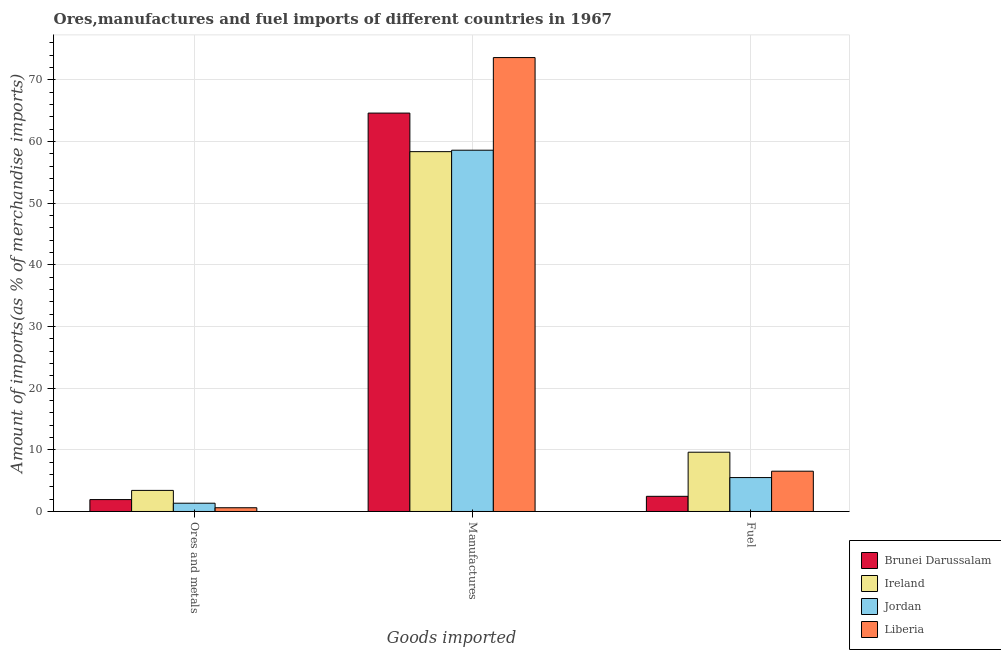How many different coloured bars are there?
Offer a very short reply. 4. How many groups of bars are there?
Keep it short and to the point. 3. What is the label of the 3rd group of bars from the left?
Make the answer very short. Fuel. What is the percentage of manufactures imports in Brunei Darussalam?
Your response must be concise. 64.62. Across all countries, what is the maximum percentage of fuel imports?
Make the answer very short. 9.61. Across all countries, what is the minimum percentage of manufactures imports?
Make the answer very short. 58.36. In which country was the percentage of fuel imports maximum?
Your answer should be very brief. Ireland. In which country was the percentage of fuel imports minimum?
Ensure brevity in your answer.  Brunei Darussalam. What is the total percentage of manufactures imports in the graph?
Your response must be concise. 255.2. What is the difference between the percentage of fuel imports in Ireland and that in Jordan?
Your response must be concise. 4.12. What is the difference between the percentage of manufactures imports in Brunei Darussalam and the percentage of fuel imports in Liberia?
Offer a terse response. 58.08. What is the average percentage of manufactures imports per country?
Offer a terse response. 63.8. What is the difference between the percentage of ores and metals imports and percentage of fuel imports in Jordan?
Provide a succinct answer. -4.16. What is the ratio of the percentage of fuel imports in Brunei Darussalam to that in Ireland?
Provide a short and direct response. 0.26. Is the difference between the percentage of ores and metals imports in Liberia and Jordan greater than the difference between the percentage of manufactures imports in Liberia and Jordan?
Keep it short and to the point. No. What is the difference between the highest and the second highest percentage of fuel imports?
Your answer should be very brief. 3.08. What is the difference between the highest and the lowest percentage of manufactures imports?
Make the answer very short. 15.26. Is the sum of the percentage of manufactures imports in Liberia and Jordan greater than the maximum percentage of ores and metals imports across all countries?
Your response must be concise. Yes. What does the 4th bar from the left in Ores and metals represents?
Your answer should be compact. Liberia. What does the 2nd bar from the right in Ores and metals represents?
Provide a succinct answer. Jordan. Is it the case that in every country, the sum of the percentage of ores and metals imports and percentage of manufactures imports is greater than the percentage of fuel imports?
Ensure brevity in your answer.  Yes. How many countries are there in the graph?
Your answer should be very brief. 4. What is the difference between two consecutive major ticks on the Y-axis?
Offer a terse response. 10. Does the graph contain any zero values?
Provide a succinct answer. No. Does the graph contain grids?
Ensure brevity in your answer.  Yes. What is the title of the graph?
Provide a succinct answer. Ores,manufactures and fuel imports of different countries in 1967. What is the label or title of the X-axis?
Your answer should be very brief. Goods imported. What is the label or title of the Y-axis?
Keep it short and to the point. Amount of imports(as % of merchandise imports). What is the Amount of imports(as % of merchandise imports) of Brunei Darussalam in Ores and metals?
Your answer should be very brief. 1.93. What is the Amount of imports(as % of merchandise imports) of Ireland in Ores and metals?
Offer a terse response. 3.42. What is the Amount of imports(as % of merchandise imports) of Jordan in Ores and metals?
Give a very brief answer. 1.34. What is the Amount of imports(as % of merchandise imports) in Liberia in Ores and metals?
Offer a terse response. 0.61. What is the Amount of imports(as % of merchandise imports) of Brunei Darussalam in Manufactures?
Ensure brevity in your answer.  64.62. What is the Amount of imports(as % of merchandise imports) in Ireland in Manufactures?
Your response must be concise. 58.36. What is the Amount of imports(as % of merchandise imports) of Jordan in Manufactures?
Offer a very short reply. 58.6. What is the Amount of imports(as % of merchandise imports) in Liberia in Manufactures?
Make the answer very short. 73.62. What is the Amount of imports(as % of merchandise imports) of Brunei Darussalam in Fuel?
Keep it short and to the point. 2.46. What is the Amount of imports(as % of merchandise imports) of Ireland in Fuel?
Provide a short and direct response. 9.61. What is the Amount of imports(as % of merchandise imports) in Jordan in Fuel?
Provide a succinct answer. 5.5. What is the Amount of imports(as % of merchandise imports) in Liberia in Fuel?
Offer a terse response. 6.53. Across all Goods imported, what is the maximum Amount of imports(as % of merchandise imports) of Brunei Darussalam?
Give a very brief answer. 64.62. Across all Goods imported, what is the maximum Amount of imports(as % of merchandise imports) in Ireland?
Provide a succinct answer. 58.36. Across all Goods imported, what is the maximum Amount of imports(as % of merchandise imports) in Jordan?
Provide a succinct answer. 58.6. Across all Goods imported, what is the maximum Amount of imports(as % of merchandise imports) in Liberia?
Your answer should be very brief. 73.62. Across all Goods imported, what is the minimum Amount of imports(as % of merchandise imports) of Brunei Darussalam?
Offer a terse response. 1.93. Across all Goods imported, what is the minimum Amount of imports(as % of merchandise imports) in Ireland?
Your answer should be very brief. 3.42. Across all Goods imported, what is the minimum Amount of imports(as % of merchandise imports) in Jordan?
Your response must be concise. 1.34. Across all Goods imported, what is the minimum Amount of imports(as % of merchandise imports) of Liberia?
Your answer should be very brief. 0.61. What is the total Amount of imports(as % of merchandise imports) in Brunei Darussalam in the graph?
Provide a short and direct response. 69.01. What is the total Amount of imports(as % of merchandise imports) in Ireland in the graph?
Make the answer very short. 71.4. What is the total Amount of imports(as % of merchandise imports) in Jordan in the graph?
Offer a very short reply. 65.44. What is the total Amount of imports(as % of merchandise imports) in Liberia in the graph?
Your answer should be compact. 80.76. What is the difference between the Amount of imports(as % of merchandise imports) in Brunei Darussalam in Ores and metals and that in Manufactures?
Ensure brevity in your answer.  -62.69. What is the difference between the Amount of imports(as % of merchandise imports) of Ireland in Ores and metals and that in Manufactures?
Provide a succinct answer. -54.94. What is the difference between the Amount of imports(as % of merchandise imports) in Jordan in Ores and metals and that in Manufactures?
Your response must be concise. -57.25. What is the difference between the Amount of imports(as % of merchandise imports) in Liberia in Ores and metals and that in Manufactures?
Offer a terse response. -73.01. What is the difference between the Amount of imports(as % of merchandise imports) in Brunei Darussalam in Ores and metals and that in Fuel?
Offer a terse response. -0.53. What is the difference between the Amount of imports(as % of merchandise imports) of Ireland in Ores and metals and that in Fuel?
Keep it short and to the point. -6.19. What is the difference between the Amount of imports(as % of merchandise imports) of Jordan in Ores and metals and that in Fuel?
Give a very brief answer. -4.16. What is the difference between the Amount of imports(as % of merchandise imports) in Liberia in Ores and metals and that in Fuel?
Give a very brief answer. -5.93. What is the difference between the Amount of imports(as % of merchandise imports) in Brunei Darussalam in Manufactures and that in Fuel?
Your response must be concise. 62.16. What is the difference between the Amount of imports(as % of merchandise imports) of Ireland in Manufactures and that in Fuel?
Your response must be concise. 48.75. What is the difference between the Amount of imports(as % of merchandise imports) in Jordan in Manufactures and that in Fuel?
Your response must be concise. 53.1. What is the difference between the Amount of imports(as % of merchandise imports) in Liberia in Manufactures and that in Fuel?
Provide a short and direct response. 67.09. What is the difference between the Amount of imports(as % of merchandise imports) of Brunei Darussalam in Ores and metals and the Amount of imports(as % of merchandise imports) of Ireland in Manufactures?
Offer a terse response. -56.43. What is the difference between the Amount of imports(as % of merchandise imports) in Brunei Darussalam in Ores and metals and the Amount of imports(as % of merchandise imports) in Jordan in Manufactures?
Offer a terse response. -56.67. What is the difference between the Amount of imports(as % of merchandise imports) of Brunei Darussalam in Ores and metals and the Amount of imports(as % of merchandise imports) of Liberia in Manufactures?
Give a very brief answer. -71.69. What is the difference between the Amount of imports(as % of merchandise imports) of Ireland in Ores and metals and the Amount of imports(as % of merchandise imports) of Jordan in Manufactures?
Offer a terse response. -55.18. What is the difference between the Amount of imports(as % of merchandise imports) of Ireland in Ores and metals and the Amount of imports(as % of merchandise imports) of Liberia in Manufactures?
Offer a very short reply. -70.2. What is the difference between the Amount of imports(as % of merchandise imports) in Jordan in Ores and metals and the Amount of imports(as % of merchandise imports) in Liberia in Manufactures?
Ensure brevity in your answer.  -72.28. What is the difference between the Amount of imports(as % of merchandise imports) in Brunei Darussalam in Ores and metals and the Amount of imports(as % of merchandise imports) in Ireland in Fuel?
Provide a short and direct response. -7.69. What is the difference between the Amount of imports(as % of merchandise imports) of Brunei Darussalam in Ores and metals and the Amount of imports(as % of merchandise imports) of Jordan in Fuel?
Offer a terse response. -3.57. What is the difference between the Amount of imports(as % of merchandise imports) in Brunei Darussalam in Ores and metals and the Amount of imports(as % of merchandise imports) in Liberia in Fuel?
Your answer should be compact. -4.61. What is the difference between the Amount of imports(as % of merchandise imports) in Ireland in Ores and metals and the Amount of imports(as % of merchandise imports) in Jordan in Fuel?
Ensure brevity in your answer.  -2.08. What is the difference between the Amount of imports(as % of merchandise imports) in Ireland in Ores and metals and the Amount of imports(as % of merchandise imports) in Liberia in Fuel?
Your answer should be compact. -3.12. What is the difference between the Amount of imports(as % of merchandise imports) of Jordan in Ores and metals and the Amount of imports(as % of merchandise imports) of Liberia in Fuel?
Provide a succinct answer. -5.19. What is the difference between the Amount of imports(as % of merchandise imports) of Brunei Darussalam in Manufactures and the Amount of imports(as % of merchandise imports) of Ireland in Fuel?
Make the answer very short. 55. What is the difference between the Amount of imports(as % of merchandise imports) of Brunei Darussalam in Manufactures and the Amount of imports(as % of merchandise imports) of Jordan in Fuel?
Your answer should be compact. 59.12. What is the difference between the Amount of imports(as % of merchandise imports) in Brunei Darussalam in Manufactures and the Amount of imports(as % of merchandise imports) in Liberia in Fuel?
Offer a terse response. 58.08. What is the difference between the Amount of imports(as % of merchandise imports) in Ireland in Manufactures and the Amount of imports(as % of merchandise imports) in Jordan in Fuel?
Ensure brevity in your answer.  52.86. What is the difference between the Amount of imports(as % of merchandise imports) in Ireland in Manufactures and the Amount of imports(as % of merchandise imports) in Liberia in Fuel?
Give a very brief answer. 51.83. What is the difference between the Amount of imports(as % of merchandise imports) in Jordan in Manufactures and the Amount of imports(as % of merchandise imports) in Liberia in Fuel?
Your answer should be compact. 52.06. What is the average Amount of imports(as % of merchandise imports) in Brunei Darussalam per Goods imported?
Your answer should be compact. 23. What is the average Amount of imports(as % of merchandise imports) in Ireland per Goods imported?
Provide a succinct answer. 23.8. What is the average Amount of imports(as % of merchandise imports) in Jordan per Goods imported?
Your answer should be compact. 21.81. What is the average Amount of imports(as % of merchandise imports) in Liberia per Goods imported?
Offer a terse response. 26.92. What is the difference between the Amount of imports(as % of merchandise imports) of Brunei Darussalam and Amount of imports(as % of merchandise imports) of Ireland in Ores and metals?
Provide a short and direct response. -1.49. What is the difference between the Amount of imports(as % of merchandise imports) in Brunei Darussalam and Amount of imports(as % of merchandise imports) in Jordan in Ores and metals?
Make the answer very short. 0.59. What is the difference between the Amount of imports(as % of merchandise imports) of Brunei Darussalam and Amount of imports(as % of merchandise imports) of Liberia in Ores and metals?
Keep it short and to the point. 1.32. What is the difference between the Amount of imports(as % of merchandise imports) in Ireland and Amount of imports(as % of merchandise imports) in Jordan in Ores and metals?
Offer a very short reply. 2.08. What is the difference between the Amount of imports(as % of merchandise imports) of Ireland and Amount of imports(as % of merchandise imports) of Liberia in Ores and metals?
Give a very brief answer. 2.81. What is the difference between the Amount of imports(as % of merchandise imports) in Jordan and Amount of imports(as % of merchandise imports) in Liberia in Ores and metals?
Your answer should be compact. 0.73. What is the difference between the Amount of imports(as % of merchandise imports) in Brunei Darussalam and Amount of imports(as % of merchandise imports) in Ireland in Manufactures?
Keep it short and to the point. 6.26. What is the difference between the Amount of imports(as % of merchandise imports) in Brunei Darussalam and Amount of imports(as % of merchandise imports) in Jordan in Manufactures?
Keep it short and to the point. 6.02. What is the difference between the Amount of imports(as % of merchandise imports) in Brunei Darussalam and Amount of imports(as % of merchandise imports) in Liberia in Manufactures?
Your answer should be compact. -9. What is the difference between the Amount of imports(as % of merchandise imports) in Ireland and Amount of imports(as % of merchandise imports) in Jordan in Manufactures?
Offer a terse response. -0.24. What is the difference between the Amount of imports(as % of merchandise imports) in Ireland and Amount of imports(as % of merchandise imports) in Liberia in Manufactures?
Give a very brief answer. -15.26. What is the difference between the Amount of imports(as % of merchandise imports) in Jordan and Amount of imports(as % of merchandise imports) in Liberia in Manufactures?
Your answer should be compact. -15.02. What is the difference between the Amount of imports(as % of merchandise imports) in Brunei Darussalam and Amount of imports(as % of merchandise imports) in Ireland in Fuel?
Your response must be concise. -7.15. What is the difference between the Amount of imports(as % of merchandise imports) in Brunei Darussalam and Amount of imports(as % of merchandise imports) in Jordan in Fuel?
Offer a very short reply. -3.04. What is the difference between the Amount of imports(as % of merchandise imports) in Brunei Darussalam and Amount of imports(as % of merchandise imports) in Liberia in Fuel?
Your response must be concise. -4.07. What is the difference between the Amount of imports(as % of merchandise imports) in Ireland and Amount of imports(as % of merchandise imports) in Jordan in Fuel?
Offer a terse response. 4.12. What is the difference between the Amount of imports(as % of merchandise imports) of Ireland and Amount of imports(as % of merchandise imports) of Liberia in Fuel?
Offer a very short reply. 3.08. What is the difference between the Amount of imports(as % of merchandise imports) of Jordan and Amount of imports(as % of merchandise imports) of Liberia in Fuel?
Ensure brevity in your answer.  -1.04. What is the ratio of the Amount of imports(as % of merchandise imports) in Brunei Darussalam in Ores and metals to that in Manufactures?
Ensure brevity in your answer.  0.03. What is the ratio of the Amount of imports(as % of merchandise imports) of Ireland in Ores and metals to that in Manufactures?
Offer a very short reply. 0.06. What is the ratio of the Amount of imports(as % of merchandise imports) of Jordan in Ores and metals to that in Manufactures?
Provide a succinct answer. 0.02. What is the ratio of the Amount of imports(as % of merchandise imports) in Liberia in Ores and metals to that in Manufactures?
Your answer should be compact. 0.01. What is the ratio of the Amount of imports(as % of merchandise imports) of Brunei Darussalam in Ores and metals to that in Fuel?
Ensure brevity in your answer.  0.78. What is the ratio of the Amount of imports(as % of merchandise imports) in Ireland in Ores and metals to that in Fuel?
Make the answer very short. 0.36. What is the ratio of the Amount of imports(as % of merchandise imports) in Jordan in Ores and metals to that in Fuel?
Provide a short and direct response. 0.24. What is the ratio of the Amount of imports(as % of merchandise imports) of Liberia in Ores and metals to that in Fuel?
Offer a very short reply. 0.09. What is the ratio of the Amount of imports(as % of merchandise imports) of Brunei Darussalam in Manufactures to that in Fuel?
Provide a succinct answer. 26.27. What is the ratio of the Amount of imports(as % of merchandise imports) of Ireland in Manufactures to that in Fuel?
Your response must be concise. 6.07. What is the ratio of the Amount of imports(as % of merchandise imports) of Jordan in Manufactures to that in Fuel?
Your response must be concise. 10.66. What is the ratio of the Amount of imports(as % of merchandise imports) in Liberia in Manufactures to that in Fuel?
Your response must be concise. 11.27. What is the difference between the highest and the second highest Amount of imports(as % of merchandise imports) of Brunei Darussalam?
Provide a short and direct response. 62.16. What is the difference between the highest and the second highest Amount of imports(as % of merchandise imports) in Ireland?
Keep it short and to the point. 48.75. What is the difference between the highest and the second highest Amount of imports(as % of merchandise imports) in Jordan?
Give a very brief answer. 53.1. What is the difference between the highest and the second highest Amount of imports(as % of merchandise imports) in Liberia?
Keep it short and to the point. 67.09. What is the difference between the highest and the lowest Amount of imports(as % of merchandise imports) in Brunei Darussalam?
Give a very brief answer. 62.69. What is the difference between the highest and the lowest Amount of imports(as % of merchandise imports) of Ireland?
Give a very brief answer. 54.94. What is the difference between the highest and the lowest Amount of imports(as % of merchandise imports) in Jordan?
Your answer should be compact. 57.25. What is the difference between the highest and the lowest Amount of imports(as % of merchandise imports) of Liberia?
Give a very brief answer. 73.01. 